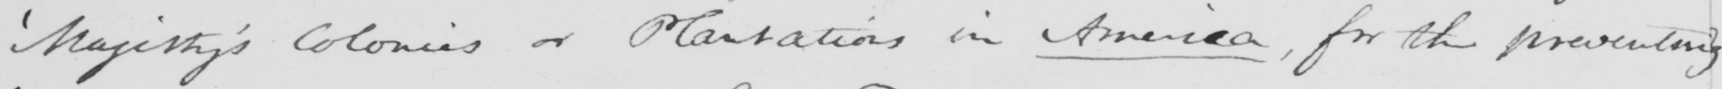Please provide the text content of this handwritten line. ' Majesty ' s Colonies or Plantations in America , for the preventing 